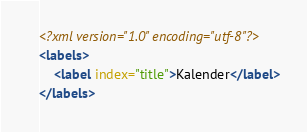<code> <loc_0><loc_0><loc_500><loc_500><_XML_><?xml version="1.0" encoding="utf-8"?>
<labels>
	<label index="title">Kalender</label>
</labels></code> 